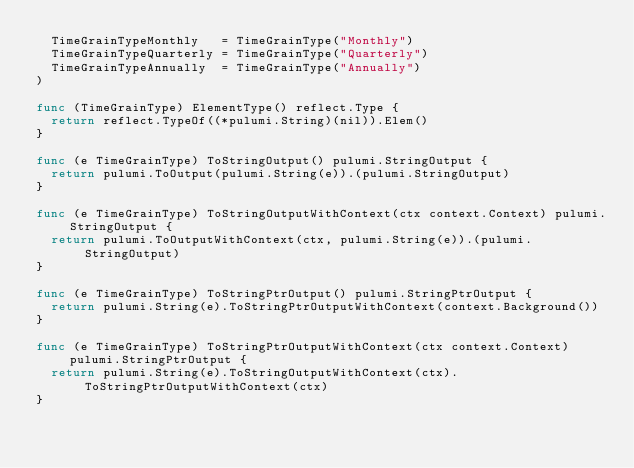Convert code to text. <code><loc_0><loc_0><loc_500><loc_500><_Go_>	TimeGrainTypeMonthly   = TimeGrainType("Monthly")
	TimeGrainTypeQuarterly = TimeGrainType("Quarterly")
	TimeGrainTypeAnnually  = TimeGrainType("Annually")
)

func (TimeGrainType) ElementType() reflect.Type {
	return reflect.TypeOf((*pulumi.String)(nil)).Elem()
}

func (e TimeGrainType) ToStringOutput() pulumi.StringOutput {
	return pulumi.ToOutput(pulumi.String(e)).(pulumi.StringOutput)
}

func (e TimeGrainType) ToStringOutputWithContext(ctx context.Context) pulumi.StringOutput {
	return pulumi.ToOutputWithContext(ctx, pulumi.String(e)).(pulumi.StringOutput)
}

func (e TimeGrainType) ToStringPtrOutput() pulumi.StringPtrOutput {
	return pulumi.String(e).ToStringPtrOutputWithContext(context.Background())
}

func (e TimeGrainType) ToStringPtrOutputWithContext(ctx context.Context) pulumi.StringPtrOutput {
	return pulumi.String(e).ToStringOutputWithContext(ctx).ToStringPtrOutputWithContext(ctx)
}
</code> 